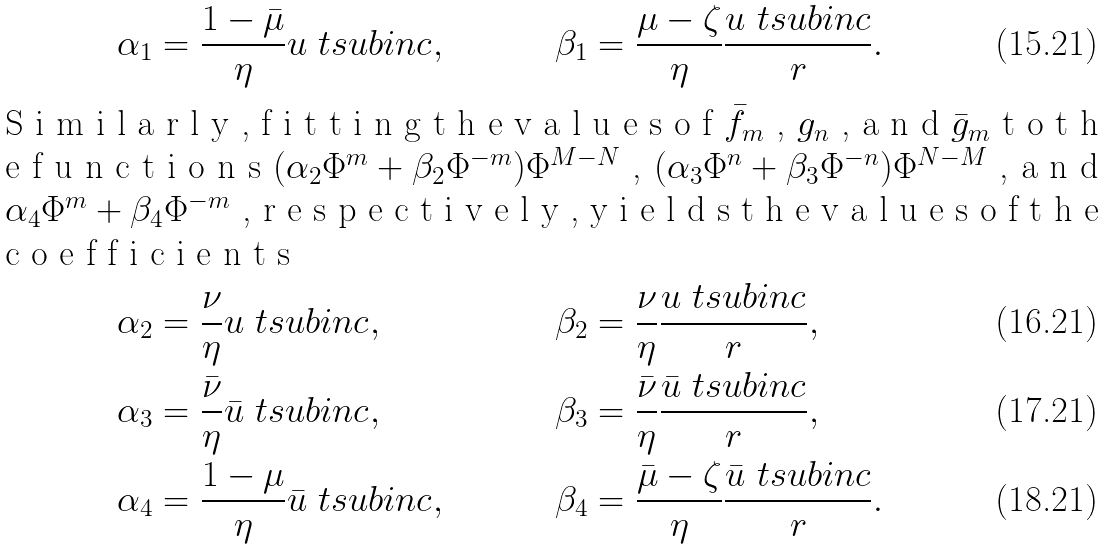Convert formula to latex. <formula><loc_0><loc_0><loc_500><loc_500>\alpha _ { 1 } & = \frac { 1 - \bar { \mu } } { \eta } u \ t s u b { i n c } , & \beta _ { 1 } & = \frac { \mu - \zeta } { \eta } \frac { u \ t s u b { i n c } } { r } . \\ \intertext { S i m i l a r l y , f i t t i n g t h e v a l u e s o f $ \bar { f } _ { m } $ , $ g _ { n } $ , a n d $ \bar { g } _ { m } $ t o t h e f u n c t i o n s $ ( \alpha _ { 2 } \Phi ^ { m } + \beta _ { 2 } \Phi ^ { - m } ) \Phi ^ { M - N } $ , $ ( \alpha _ { 3 } \Phi ^ { n } + \beta _ { 3 } \Phi ^ { - n } ) \Phi ^ { N - M } $ , a n d $ \alpha _ { 4 } \Phi ^ { m } + \beta _ { 4 } \Phi ^ { - m } $ , r e s p e c t i v e l y , y i e l d s t h e v a l u e s o f t h e c o e f f i c i e n t s } \alpha _ { 2 } & = \frac { \nu } { \eta } u \ t s u b { i n c } , & \beta _ { 2 } & = \frac { \nu } { \eta } \frac { u \ t s u b { i n c } } { r } , \\ \alpha _ { 3 } & = \frac { \bar { \nu } } { \eta } \bar { u } \ t s u b { i n c } , & \beta _ { 3 } & = \frac { \bar { \nu } } { \eta } \frac { \bar { u } \ t s u b { i n c } } { r } , \\ \alpha _ { 4 } & = \frac { 1 - \mu } { \eta } \bar { u } \ t s u b { i n c } , & \beta _ { 4 } & = \frac { \bar { \mu } - \zeta } { \eta } \frac { \bar { u } \ t s u b { i n c } } { r } .</formula> 